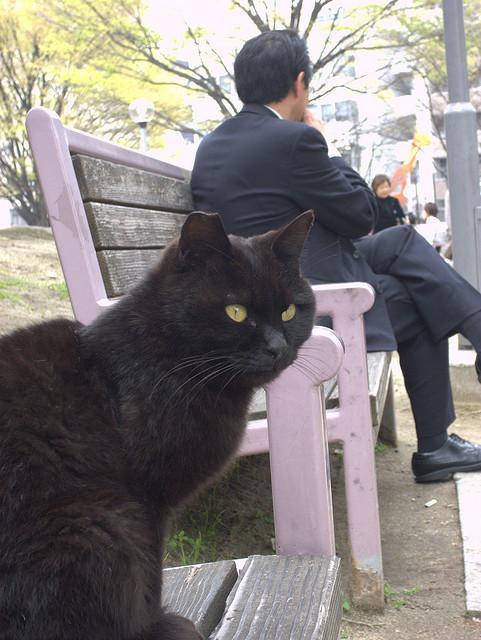What animal is on the bench?
From the following set of four choices, select the accurate answer to respond to the question.
Options: Dog, black cat, orange cat, badger. Black cat. 